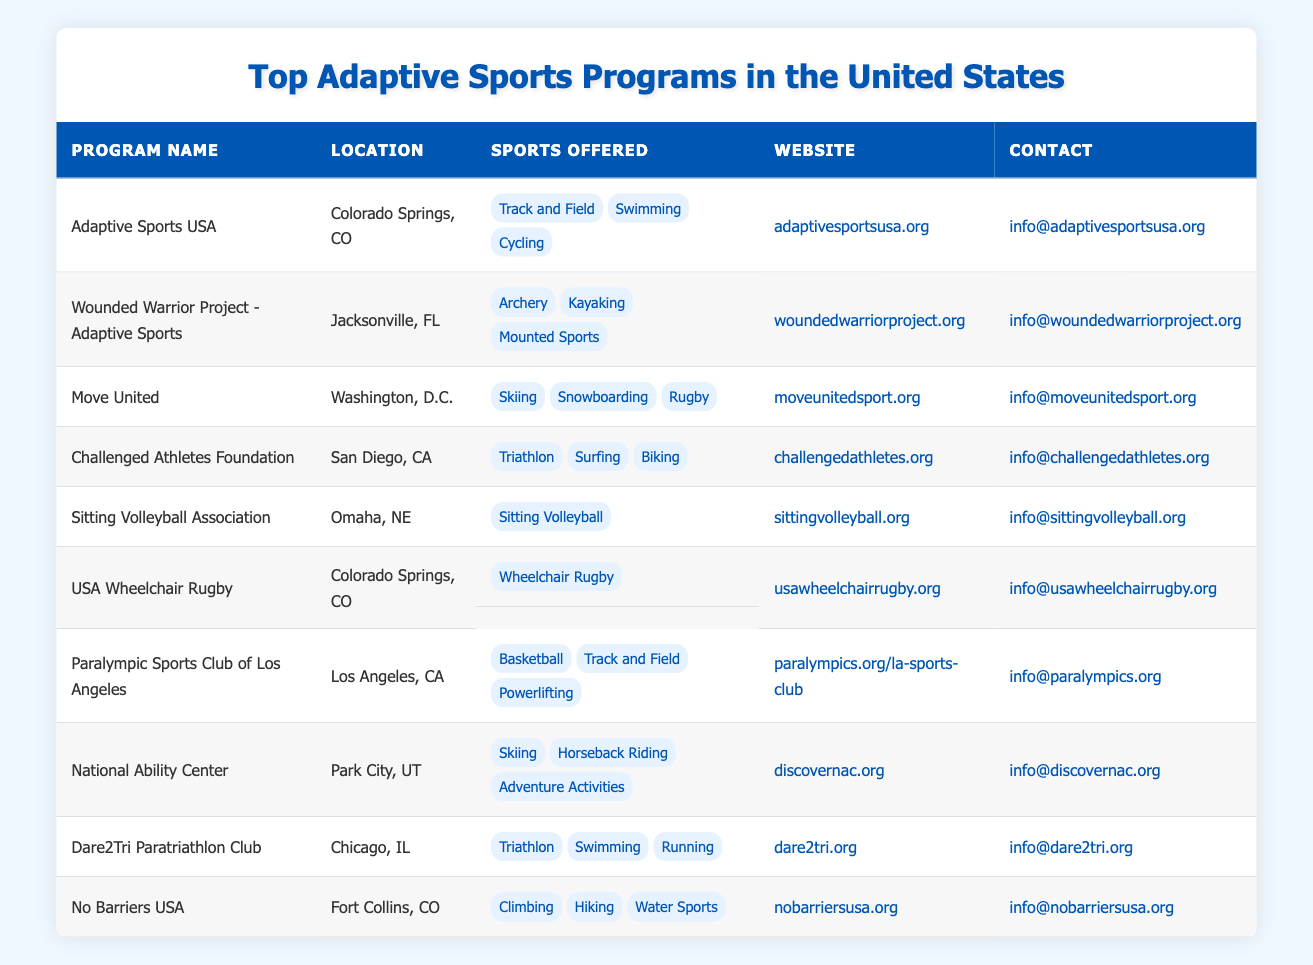What is the location of the Adaptive Sports USA program? The table lists the program "Adaptive Sports USA" and its corresponding location next to it, which shows it is in Colorado Springs, CO.
Answer: Colorado Springs, CO How many sports are offered by the Wounded Warrior Project - Adaptive Sports? By looking at the Wounded Warrior Project - Adaptive Sports entry, we can count that there are three sports listed: Archery, Kayaking, and Mounted Sports.
Answer: 3 What are the sports offered by the Paralympic Sports Club of Los Angeles? The table shows the entry for the Paralympic Sports Club of Los Angeles, where the sports listed are Basketball, Track and Field, and Powerlifting.
Answer: Basketball, Track and Field, Powerlifting Which program offers Wheelchair Rugby? By examining the table, we find that the program offering Wheelchair Rugby is USA Wheelchair Rugby, located in Colorado Springs, CO.
Answer: USA Wheelchair Rugby Is there a program based in Omaha, NE? The table indicates there is a program listed with the location of Omaha, NE, which is the Sitting Volleyball Association.
Answer: Yes Which program offers the most sports? To determine this, we need to count the sports offered by each program. The program with the most is the Challenged Athletes Foundation, which offers three sports: Triathlon, Surfing, and Biking.
Answer: Challenged Athletes Foundation Which city has the most adaptive sports programs listed? Analyzing the location column, we note Colorado Springs, CO has three programs listed: Adaptive Sports USA, USA Wheelchair Rugby, and No Barriers USA, making it the city with the most programs.
Answer: Colorado Springs, CO Does the National Ability Center offer Horseback Riding? Looking at the National Ability Center entry, we see that it does indeed offer Horseback Riding as one of its sports.
Answer: Yes What is the contact email for Dare2Tri Paratriathlon Club? The contact email is provided in the table's entry for Dare2Tri Paratriathlon Club: info@dare2tri.org.
Answer: info@dare2tri.org What types of sports does Move United promote? In reviewing the Move United entry in the table, it lists skiing, snowboarding, and rugby as the sports offered by the program.
Answer: Skiing, Snowboarding, Rugby What is the total number of unique locations for the adaptive sports programs listed? By counting the different locations in the table, we find there are eight unique locations: Colorado Springs, Jacksonville, Washington, San Diego, Omaha, Los Angeles, Park City, and Fort Collins.
Answer: 8 